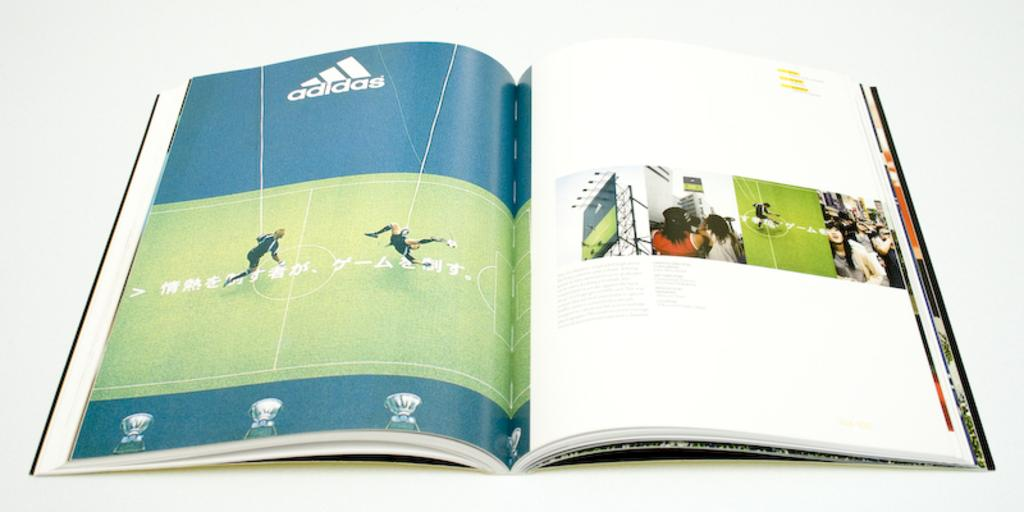<image>
Write a terse but informative summary of the picture. A magazine open to an advertisement from Adidas. 